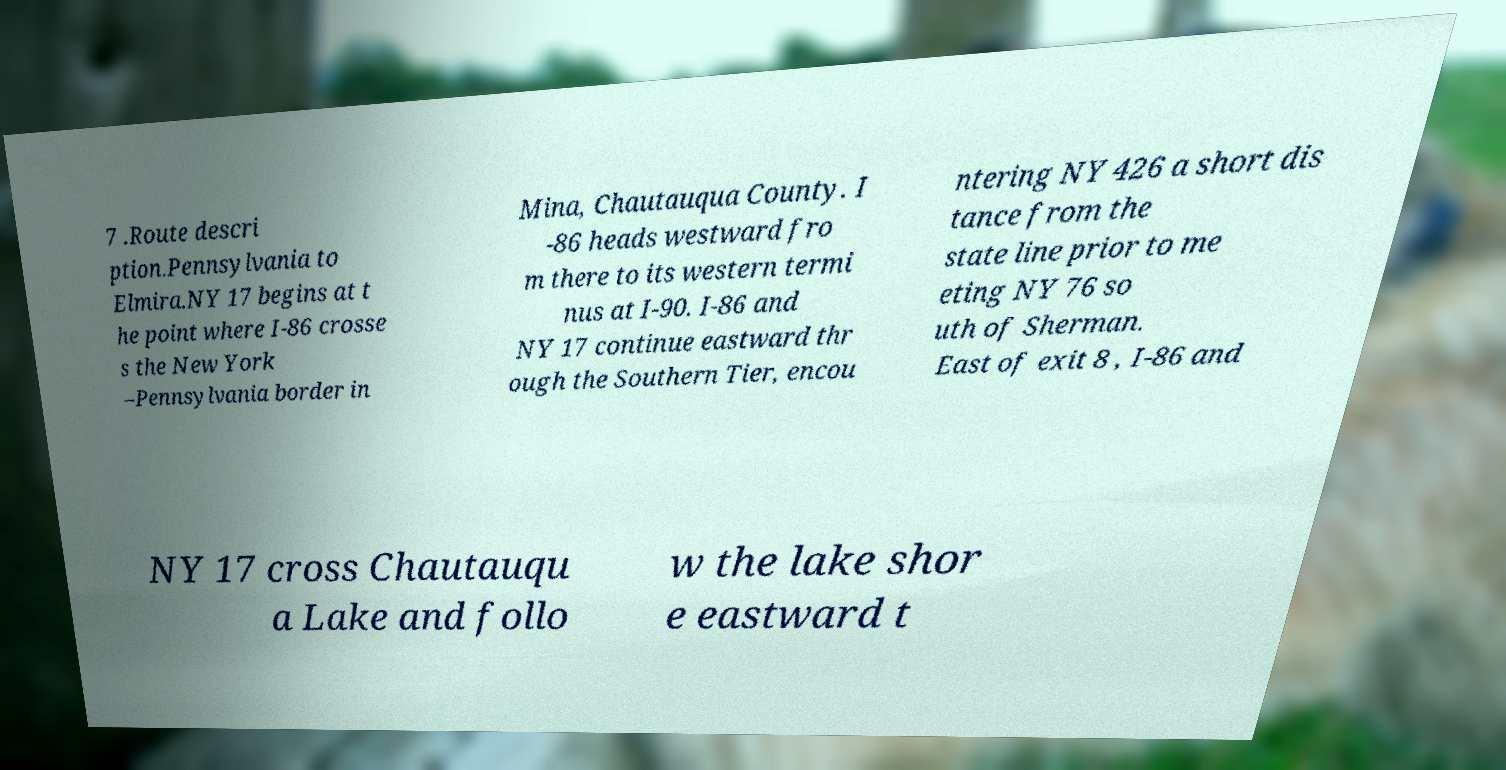Could you extract and type out the text from this image? 7 .Route descri ption.Pennsylvania to Elmira.NY 17 begins at t he point where I-86 crosse s the New York –Pennsylvania border in Mina, Chautauqua County. I -86 heads westward fro m there to its western termi nus at I-90. I-86 and NY 17 continue eastward thr ough the Southern Tier, encou ntering NY 426 a short dis tance from the state line prior to me eting NY 76 so uth of Sherman. East of exit 8 , I-86 and NY 17 cross Chautauqu a Lake and follo w the lake shor e eastward t 